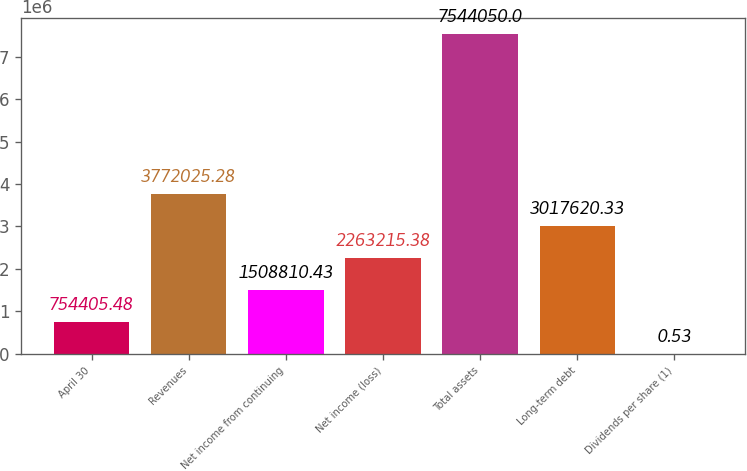<chart> <loc_0><loc_0><loc_500><loc_500><bar_chart><fcel>April 30<fcel>Revenues<fcel>Net income from continuing<fcel>Net income (loss)<fcel>Total assets<fcel>Long-term debt<fcel>Dividends per share (1)<nl><fcel>754405<fcel>3.77203e+06<fcel>1.50881e+06<fcel>2.26322e+06<fcel>7.54405e+06<fcel>3.01762e+06<fcel>0.53<nl></chart> 